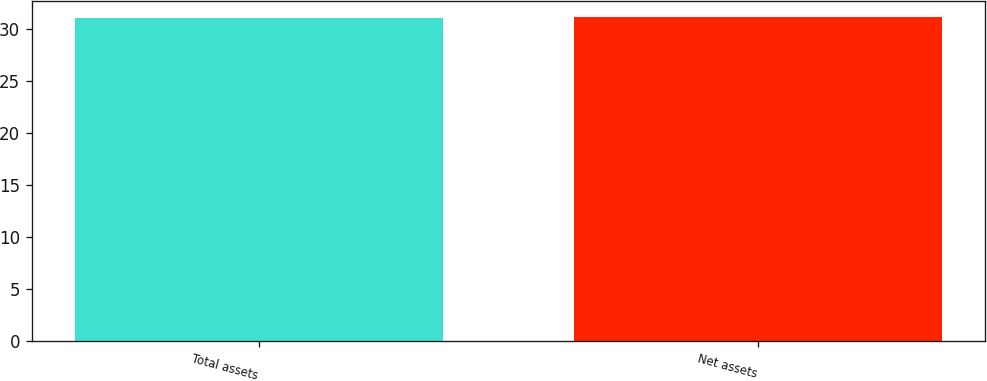Convert chart. <chart><loc_0><loc_0><loc_500><loc_500><bar_chart><fcel>Total assets<fcel>Net assets<nl><fcel>31<fcel>31.1<nl></chart> 